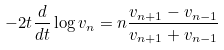Convert formula to latex. <formula><loc_0><loc_0><loc_500><loc_500>- 2 t \frac { d } { d t } \log v _ { n } = n \frac { v _ { n + 1 } - v _ { n - 1 } } { v _ { n + 1 } + v _ { n - 1 } }</formula> 